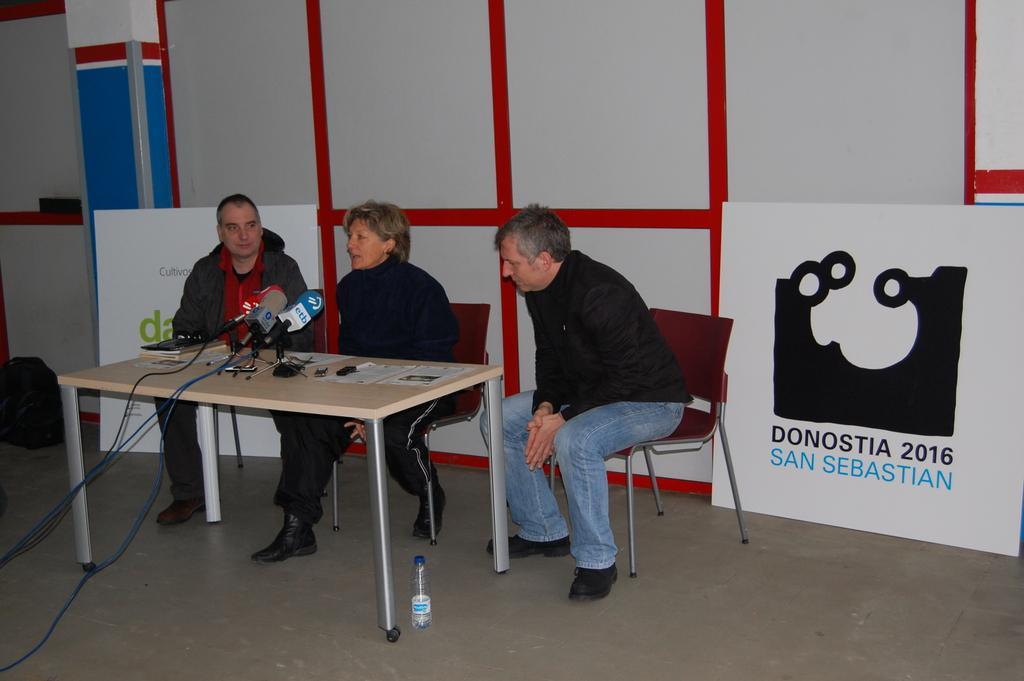Can you describe this image briefly? 3 people are sitting on the red chair. the person at the center is speaking. in front of them there is a table on which there are papers, microphones. on the floor there is a bottle. behind them there is a red and white wall. at the right there is a board on which donostia 2016 is written. 